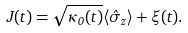<formula> <loc_0><loc_0><loc_500><loc_500>J ( t ) = \sqrt { \kappa _ { 0 } ( t ) } \langle \hat { \sigma } _ { z } \rangle + \xi ( t ) .</formula> 